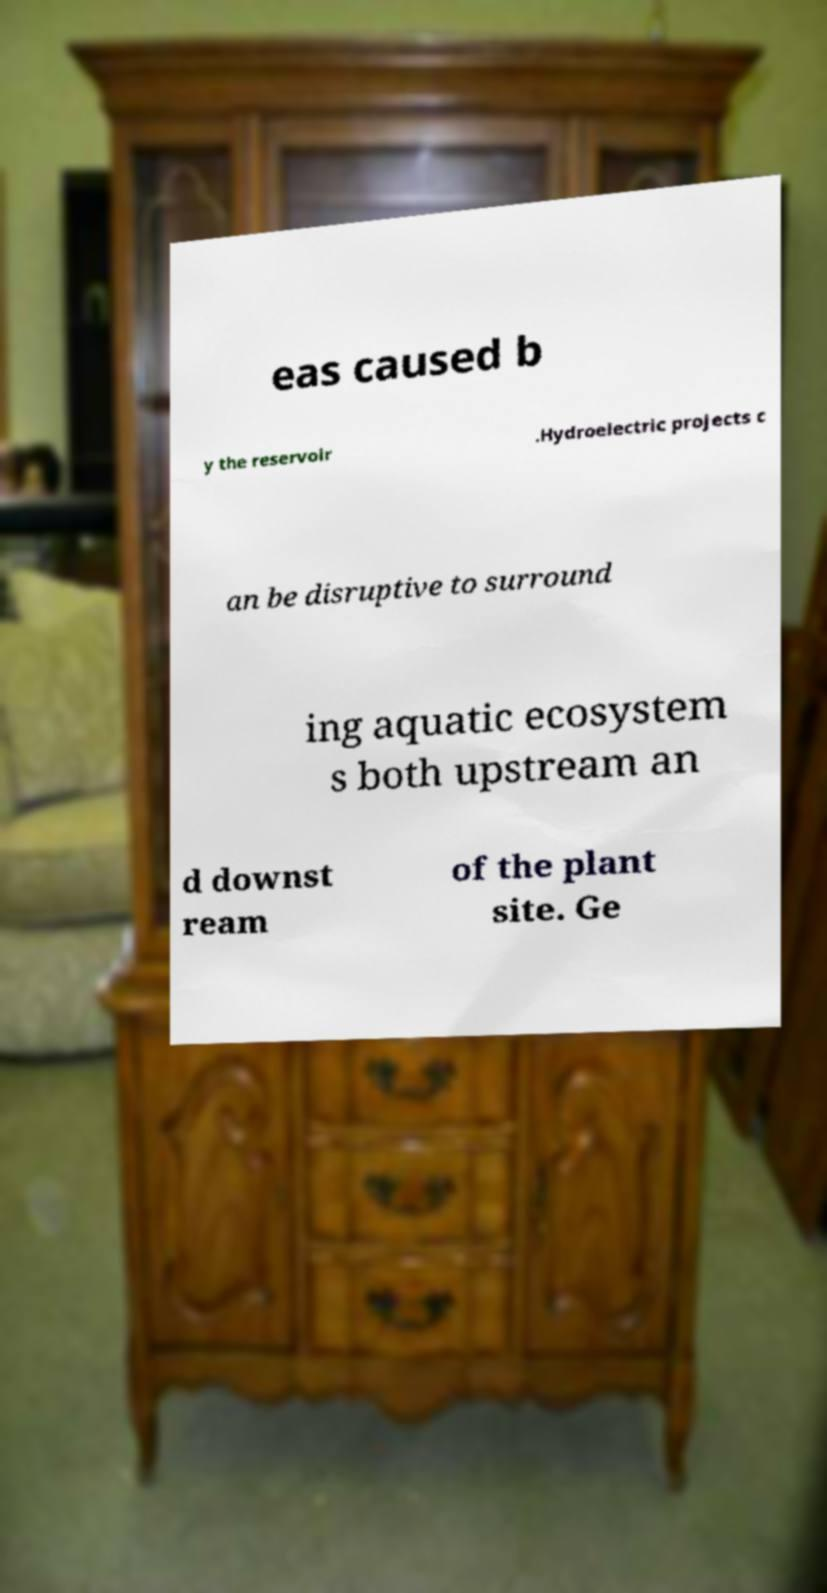Can you accurately transcribe the text from the provided image for me? eas caused b y the reservoir .Hydroelectric projects c an be disruptive to surround ing aquatic ecosystem s both upstream an d downst ream of the plant site. Ge 